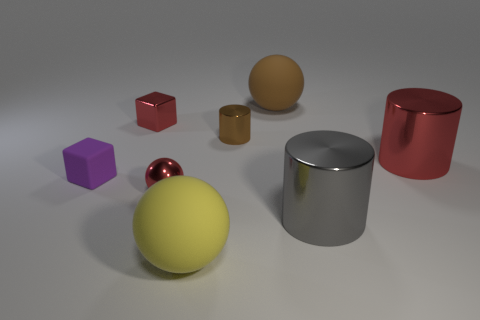How many yellow spheres are the same material as the large brown sphere?
Offer a very short reply. 1. The small metallic sphere is what color?
Give a very brief answer. Red. There is a small red metallic block; are there any small red things in front of it?
Your response must be concise. Yes. Do the metal sphere and the tiny cylinder have the same color?
Offer a terse response. No. What number of small blocks are the same color as the small cylinder?
Provide a short and direct response. 0. What is the size of the brown thing that is left of the big object that is behind the red cube?
Your answer should be very brief. Small. What is the shape of the tiny brown metallic object?
Ensure brevity in your answer.  Cylinder. There is a brown thing on the right side of the tiny brown metal cylinder; what is it made of?
Give a very brief answer. Rubber. What is the color of the big rubber sphere that is behind the large rubber ball in front of the small shiny cylinder left of the gray shiny cylinder?
Offer a very short reply. Brown. The cube that is the same size as the purple object is what color?
Provide a short and direct response. Red. 